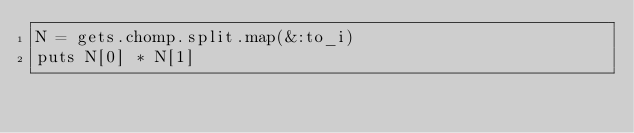<code> <loc_0><loc_0><loc_500><loc_500><_Rust_>N = gets.chomp.split.map(&:to_i)
puts N[0] * N[1]</code> 